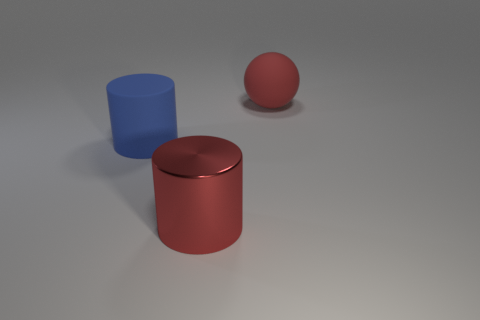Add 3 big red cylinders. How many objects exist? 6 Subtract 1 cylinders. How many cylinders are left? 1 Subtract 0 green blocks. How many objects are left? 3 Subtract all cylinders. How many objects are left? 1 Subtract all blue cylinders. Subtract all yellow balls. How many cylinders are left? 1 Subtract all blue things. Subtract all big blue objects. How many objects are left? 1 Add 2 large blue rubber cylinders. How many large blue rubber cylinders are left? 3 Add 3 shiny cylinders. How many shiny cylinders exist? 4 